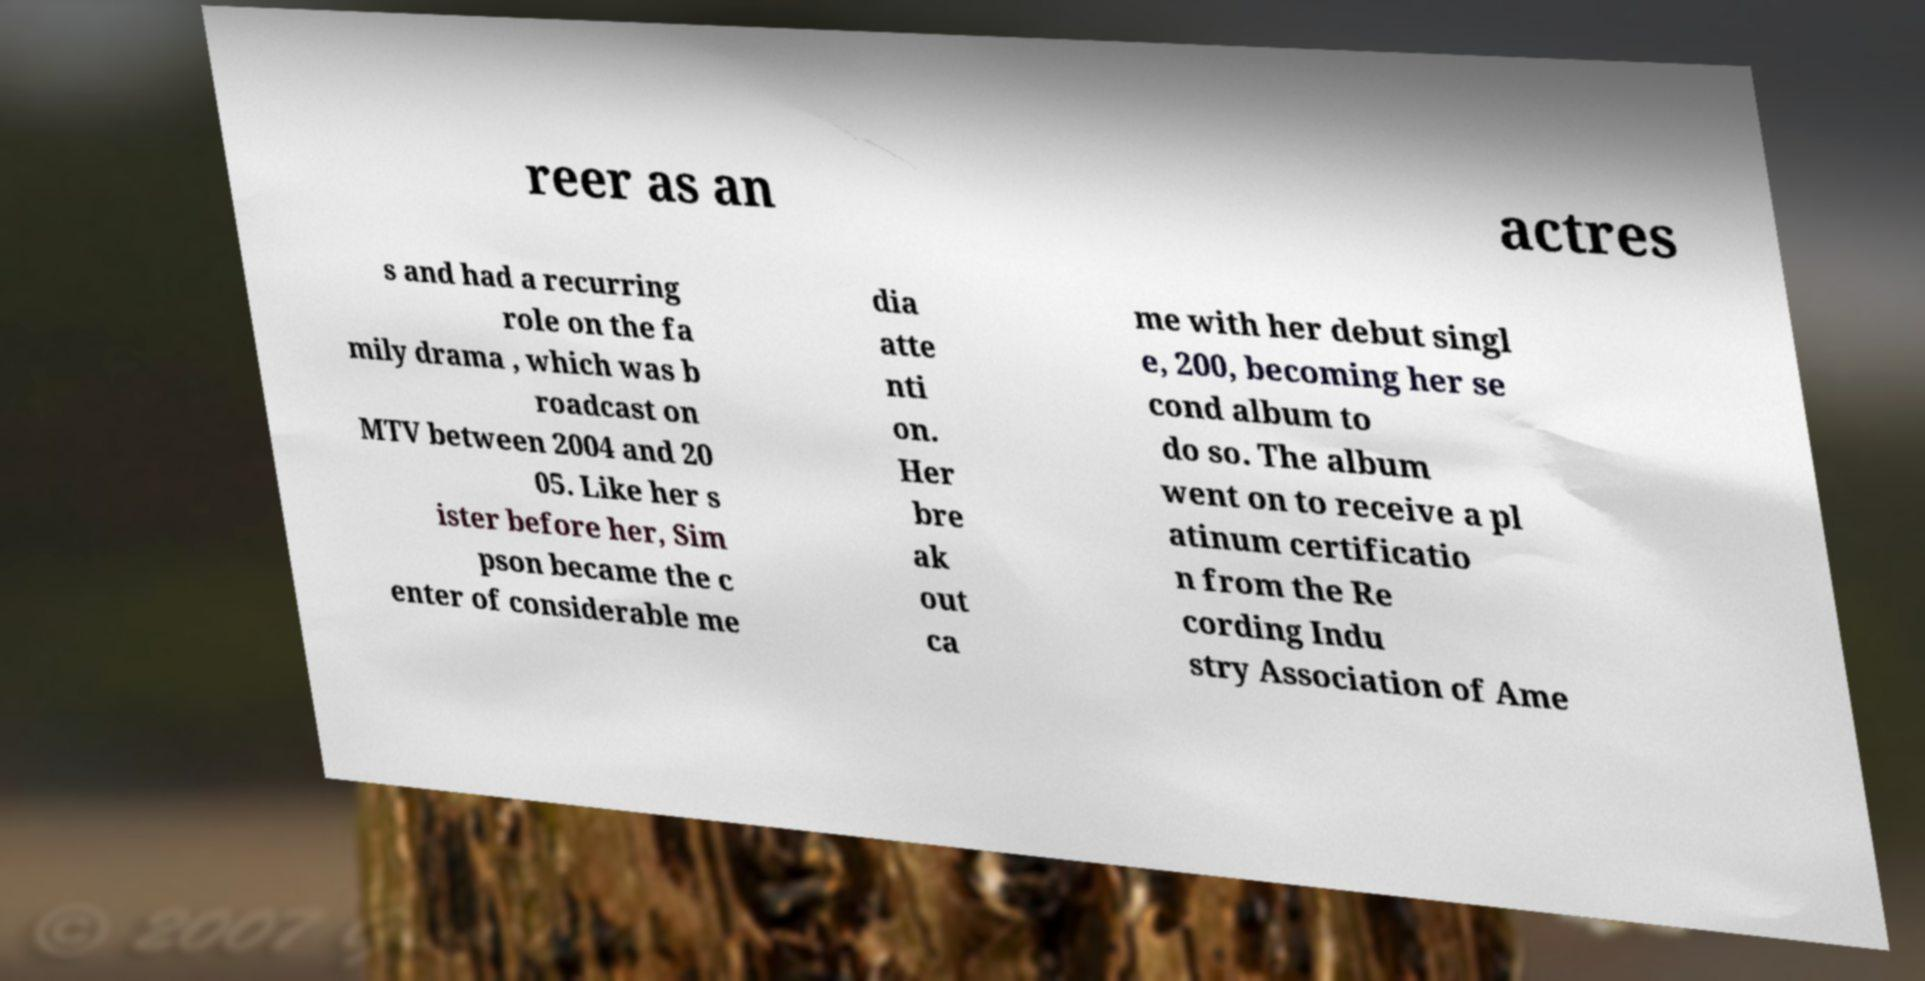Could you extract and type out the text from this image? reer as an actres s and had a recurring role on the fa mily drama , which was b roadcast on MTV between 2004 and 20 05. Like her s ister before her, Sim pson became the c enter of considerable me dia atte nti on. Her bre ak out ca me with her debut singl e, 200, becoming her se cond album to do so. The album went on to receive a pl atinum certificatio n from the Re cording Indu stry Association of Ame 